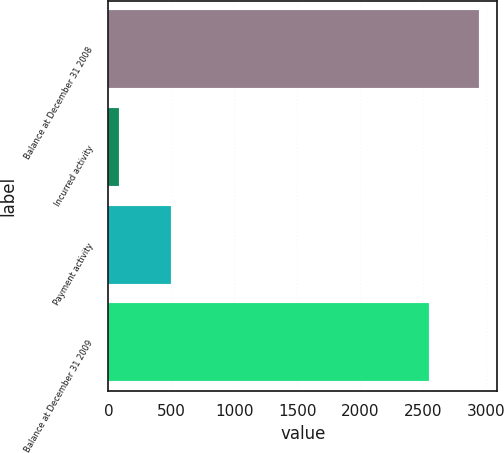Convert chart to OTSL. <chart><loc_0><loc_0><loc_500><loc_500><bar_chart><fcel>Balance at December 31 2008<fcel>Incurred activity<fcel>Payment activity<fcel>Balance at December 31 2009<nl><fcel>2939<fcel>85<fcel>498<fcel>2545<nl></chart> 